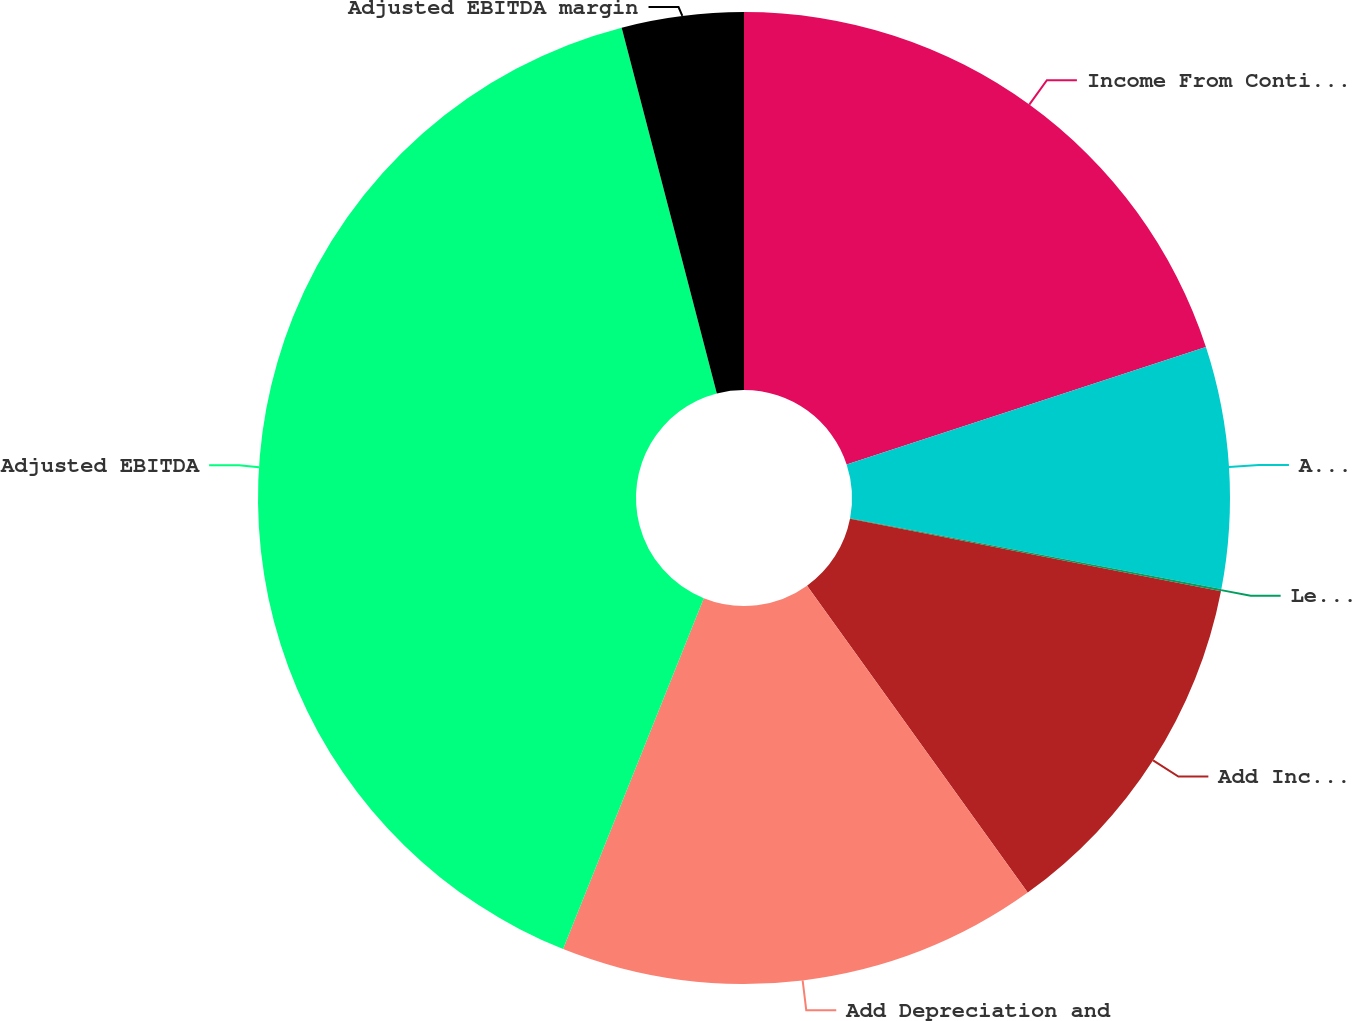Convert chart to OTSL. <chart><loc_0><loc_0><loc_500><loc_500><pie_chart><fcel>Income From Continuing<fcel>Add Interest expense<fcel>Less Other non-operating<fcel>Add Income tax provision<fcel>Add Depreciation and<fcel>Adjusted EBITDA<fcel>Adjusted EBITDA margin<nl><fcel>19.97%<fcel>8.03%<fcel>0.07%<fcel>12.01%<fcel>15.99%<fcel>39.88%<fcel>4.05%<nl></chart> 